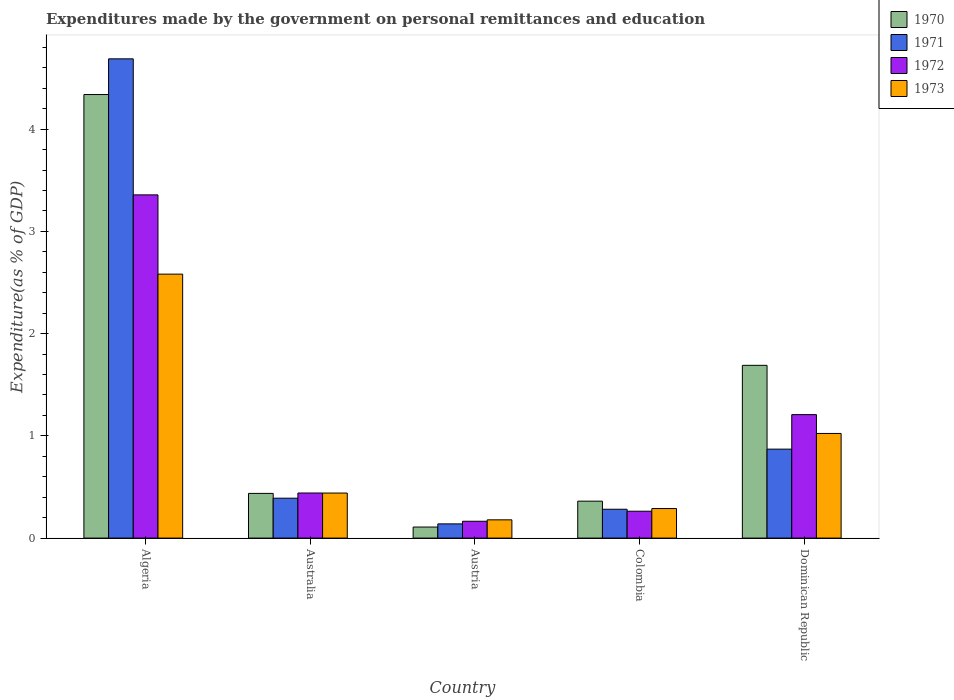How many different coloured bars are there?
Ensure brevity in your answer.  4. How many groups of bars are there?
Your answer should be compact. 5. Are the number of bars on each tick of the X-axis equal?
Offer a terse response. Yes. How many bars are there on the 5th tick from the left?
Provide a short and direct response. 4. What is the label of the 3rd group of bars from the left?
Make the answer very short. Austria. In how many cases, is the number of bars for a given country not equal to the number of legend labels?
Provide a short and direct response. 0. What is the expenditures made by the government on personal remittances and education in 1973 in Australia?
Ensure brevity in your answer.  0.44. Across all countries, what is the maximum expenditures made by the government on personal remittances and education in 1973?
Ensure brevity in your answer.  2.58. Across all countries, what is the minimum expenditures made by the government on personal remittances and education in 1973?
Ensure brevity in your answer.  0.18. In which country was the expenditures made by the government on personal remittances and education in 1971 maximum?
Provide a succinct answer. Algeria. In which country was the expenditures made by the government on personal remittances and education in 1970 minimum?
Your answer should be compact. Austria. What is the total expenditures made by the government on personal remittances and education in 1973 in the graph?
Your answer should be compact. 4.51. What is the difference between the expenditures made by the government on personal remittances and education in 1973 in Australia and that in Dominican Republic?
Your answer should be compact. -0.58. What is the difference between the expenditures made by the government on personal remittances and education in 1973 in Colombia and the expenditures made by the government on personal remittances and education in 1971 in Dominican Republic?
Your answer should be compact. -0.58. What is the average expenditures made by the government on personal remittances and education in 1971 per country?
Make the answer very short. 1.27. What is the difference between the expenditures made by the government on personal remittances and education of/in 1972 and expenditures made by the government on personal remittances and education of/in 1970 in Algeria?
Provide a succinct answer. -0.98. What is the ratio of the expenditures made by the government on personal remittances and education in 1972 in Australia to that in Austria?
Provide a short and direct response. 2.68. What is the difference between the highest and the second highest expenditures made by the government on personal remittances and education in 1971?
Provide a short and direct response. 0.48. What is the difference between the highest and the lowest expenditures made by the government on personal remittances and education in 1973?
Offer a terse response. 2.4. Is the sum of the expenditures made by the government on personal remittances and education in 1971 in Australia and Colombia greater than the maximum expenditures made by the government on personal remittances and education in 1973 across all countries?
Make the answer very short. No. Is it the case that in every country, the sum of the expenditures made by the government on personal remittances and education in 1973 and expenditures made by the government on personal remittances and education in 1970 is greater than the sum of expenditures made by the government on personal remittances and education in 1971 and expenditures made by the government on personal remittances and education in 1972?
Ensure brevity in your answer.  No. What does the 1st bar from the left in Australia represents?
Keep it short and to the point. 1970. What does the 3rd bar from the right in Australia represents?
Your answer should be very brief. 1971. Is it the case that in every country, the sum of the expenditures made by the government on personal remittances and education in 1973 and expenditures made by the government on personal remittances and education in 1972 is greater than the expenditures made by the government on personal remittances and education in 1971?
Offer a terse response. Yes. How many bars are there?
Your answer should be compact. 20. Are all the bars in the graph horizontal?
Your answer should be compact. No. How many countries are there in the graph?
Offer a terse response. 5. Does the graph contain any zero values?
Keep it short and to the point. No. How many legend labels are there?
Offer a terse response. 4. How are the legend labels stacked?
Give a very brief answer. Vertical. What is the title of the graph?
Give a very brief answer. Expenditures made by the government on personal remittances and education. Does "1999" appear as one of the legend labels in the graph?
Your answer should be compact. No. What is the label or title of the X-axis?
Keep it short and to the point. Country. What is the label or title of the Y-axis?
Your answer should be compact. Expenditure(as % of GDP). What is the Expenditure(as % of GDP) of 1970 in Algeria?
Your answer should be compact. 4.34. What is the Expenditure(as % of GDP) in 1971 in Algeria?
Offer a terse response. 4.69. What is the Expenditure(as % of GDP) in 1972 in Algeria?
Provide a short and direct response. 3.36. What is the Expenditure(as % of GDP) of 1973 in Algeria?
Make the answer very short. 2.58. What is the Expenditure(as % of GDP) in 1970 in Australia?
Keep it short and to the point. 0.44. What is the Expenditure(as % of GDP) in 1971 in Australia?
Give a very brief answer. 0.39. What is the Expenditure(as % of GDP) of 1972 in Australia?
Keep it short and to the point. 0.44. What is the Expenditure(as % of GDP) in 1973 in Australia?
Give a very brief answer. 0.44. What is the Expenditure(as % of GDP) in 1970 in Austria?
Give a very brief answer. 0.11. What is the Expenditure(as % of GDP) of 1971 in Austria?
Offer a terse response. 0.14. What is the Expenditure(as % of GDP) in 1972 in Austria?
Offer a terse response. 0.16. What is the Expenditure(as % of GDP) in 1973 in Austria?
Your answer should be compact. 0.18. What is the Expenditure(as % of GDP) in 1970 in Colombia?
Keep it short and to the point. 0.36. What is the Expenditure(as % of GDP) in 1971 in Colombia?
Keep it short and to the point. 0.28. What is the Expenditure(as % of GDP) in 1972 in Colombia?
Make the answer very short. 0.26. What is the Expenditure(as % of GDP) in 1973 in Colombia?
Keep it short and to the point. 0.29. What is the Expenditure(as % of GDP) in 1970 in Dominican Republic?
Make the answer very short. 1.69. What is the Expenditure(as % of GDP) in 1971 in Dominican Republic?
Offer a very short reply. 0.87. What is the Expenditure(as % of GDP) of 1972 in Dominican Republic?
Provide a short and direct response. 1.21. What is the Expenditure(as % of GDP) of 1973 in Dominican Republic?
Your answer should be compact. 1.02. Across all countries, what is the maximum Expenditure(as % of GDP) of 1970?
Offer a very short reply. 4.34. Across all countries, what is the maximum Expenditure(as % of GDP) of 1971?
Your response must be concise. 4.69. Across all countries, what is the maximum Expenditure(as % of GDP) of 1972?
Your response must be concise. 3.36. Across all countries, what is the maximum Expenditure(as % of GDP) of 1973?
Give a very brief answer. 2.58. Across all countries, what is the minimum Expenditure(as % of GDP) of 1970?
Your answer should be compact. 0.11. Across all countries, what is the minimum Expenditure(as % of GDP) of 1971?
Give a very brief answer. 0.14. Across all countries, what is the minimum Expenditure(as % of GDP) in 1972?
Give a very brief answer. 0.16. Across all countries, what is the minimum Expenditure(as % of GDP) of 1973?
Your answer should be very brief. 0.18. What is the total Expenditure(as % of GDP) in 1970 in the graph?
Your answer should be very brief. 6.93. What is the total Expenditure(as % of GDP) of 1971 in the graph?
Offer a terse response. 6.37. What is the total Expenditure(as % of GDP) of 1972 in the graph?
Provide a succinct answer. 5.43. What is the total Expenditure(as % of GDP) in 1973 in the graph?
Offer a very short reply. 4.51. What is the difference between the Expenditure(as % of GDP) in 1970 in Algeria and that in Australia?
Make the answer very short. 3.9. What is the difference between the Expenditure(as % of GDP) of 1971 in Algeria and that in Australia?
Provide a short and direct response. 4.3. What is the difference between the Expenditure(as % of GDP) in 1972 in Algeria and that in Australia?
Give a very brief answer. 2.92. What is the difference between the Expenditure(as % of GDP) of 1973 in Algeria and that in Australia?
Your answer should be very brief. 2.14. What is the difference between the Expenditure(as % of GDP) in 1970 in Algeria and that in Austria?
Offer a terse response. 4.23. What is the difference between the Expenditure(as % of GDP) of 1971 in Algeria and that in Austria?
Provide a succinct answer. 4.55. What is the difference between the Expenditure(as % of GDP) of 1972 in Algeria and that in Austria?
Your answer should be compact. 3.19. What is the difference between the Expenditure(as % of GDP) in 1973 in Algeria and that in Austria?
Ensure brevity in your answer.  2.4. What is the difference between the Expenditure(as % of GDP) of 1970 in Algeria and that in Colombia?
Provide a succinct answer. 3.98. What is the difference between the Expenditure(as % of GDP) in 1971 in Algeria and that in Colombia?
Make the answer very short. 4.41. What is the difference between the Expenditure(as % of GDP) of 1972 in Algeria and that in Colombia?
Provide a succinct answer. 3.09. What is the difference between the Expenditure(as % of GDP) in 1973 in Algeria and that in Colombia?
Make the answer very short. 2.29. What is the difference between the Expenditure(as % of GDP) of 1970 in Algeria and that in Dominican Republic?
Provide a succinct answer. 2.65. What is the difference between the Expenditure(as % of GDP) in 1971 in Algeria and that in Dominican Republic?
Ensure brevity in your answer.  3.82. What is the difference between the Expenditure(as % of GDP) of 1972 in Algeria and that in Dominican Republic?
Offer a very short reply. 2.15. What is the difference between the Expenditure(as % of GDP) of 1973 in Algeria and that in Dominican Republic?
Keep it short and to the point. 1.56. What is the difference between the Expenditure(as % of GDP) in 1970 in Australia and that in Austria?
Provide a succinct answer. 0.33. What is the difference between the Expenditure(as % of GDP) of 1971 in Australia and that in Austria?
Give a very brief answer. 0.25. What is the difference between the Expenditure(as % of GDP) in 1972 in Australia and that in Austria?
Provide a succinct answer. 0.28. What is the difference between the Expenditure(as % of GDP) in 1973 in Australia and that in Austria?
Make the answer very short. 0.26. What is the difference between the Expenditure(as % of GDP) of 1970 in Australia and that in Colombia?
Give a very brief answer. 0.08. What is the difference between the Expenditure(as % of GDP) in 1971 in Australia and that in Colombia?
Make the answer very short. 0.11. What is the difference between the Expenditure(as % of GDP) of 1972 in Australia and that in Colombia?
Offer a terse response. 0.18. What is the difference between the Expenditure(as % of GDP) of 1973 in Australia and that in Colombia?
Give a very brief answer. 0.15. What is the difference between the Expenditure(as % of GDP) in 1970 in Australia and that in Dominican Republic?
Give a very brief answer. -1.25. What is the difference between the Expenditure(as % of GDP) of 1971 in Australia and that in Dominican Republic?
Your answer should be compact. -0.48. What is the difference between the Expenditure(as % of GDP) of 1972 in Australia and that in Dominican Republic?
Your response must be concise. -0.77. What is the difference between the Expenditure(as % of GDP) in 1973 in Australia and that in Dominican Republic?
Your answer should be very brief. -0.58. What is the difference between the Expenditure(as % of GDP) in 1970 in Austria and that in Colombia?
Your answer should be very brief. -0.25. What is the difference between the Expenditure(as % of GDP) in 1971 in Austria and that in Colombia?
Keep it short and to the point. -0.14. What is the difference between the Expenditure(as % of GDP) of 1972 in Austria and that in Colombia?
Provide a succinct answer. -0.1. What is the difference between the Expenditure(as % of GDP) of 1973 in Austria and that in Colombia?
Offer a terse response. -0.11. What is the difference between the Expenditure(as % of GDP) of 1970 in Austria and that in Dominican Republic?
Ensure brevity in your answer.  -1.58. What is the difference between the Expenditure(as % of GDP) of 1971 in Austria and that in Dominican Republic?
Offer a very short reply. -0.73. What is the difference between the Expenditure(as % of GDP) in 1972 in Austria and that in Dominican Republic?
Offer a terse response. -1.04. What is the difference between the Expenditure(as % of GDP) in 1973 in Austria and that in Dominican Republic?
Offer a very short reply. -0.84. What is the difference between the Expenditure(as % of GDP) of 1970 in Colombia and that in Dominican Republic?
Your answer should be compact. -1.33. What is the difference between the Expenditure(as % of GDP) in 1971 in Colombia and that in Dominican Republic?
Make the answer very short. -0.59. What is the difference between the Expenditure(as % of GDP) of 1972 in Colombia and that in Dominican Republic?
Ensure brevity in your answer.  -0.94. What is the difference between the Expenditure(as % of GDP) of 1973 in Colombia and that in Dominican Republic?
Make the answer very short. -0.73. What is the difference between the Expenditure(as % of GDP) of 1970 in Algeria and the Expenditure(as % of GDP) of 1971 in Australia?
Make the answer very short. 3.95. What is the difference between the Expenditure(as % of GDP) of 1970 in Algeria and the Expenditure(as % of GDP) of 1972 in Australia?
Offer a very short reply. 3.9. What is the difference between the Expenditure(as % of GDP) in 1970 in Algeria and the Expenditure(as % of GDP) in 1973 in Australia?
Offer a terse response. 3.9. What is the difference between the Expenditure(as % of GDP) in 1971 in Algeria and the Expenditure(as % of GDP) in 1972 in Australia?
Make the answer very short. 4.25. What is the difference between the Expenditure(as % of GDP) in 1971 in Algeria and the Expenditure(as % of GDP) in 1973 in Australia?
Make the answer very short. 4.25. What is the difference between the Expenditure(as % of GDP) of 1972 in Algeria and the Expenditure(as % of GDP) of 1973 in Australia?
Your response must be concise. 2.92. What is the difference between the Expenditure(as % of GDP) of 1970 in Algeria and the Expenditure(as % of GDP) of 1971 in Austria?
Offer a terse response. 4.2. What is the difference between the Expenditure(as % of GDP) in 1970 in Algeria and the Expenditure(as % of GDP) in 1972 in Austria?
Your answer should be very brief. 4.17. What is the difference between the Expenditure(as % of GDP) of 1970 in Algeria and the Expenditure(as % of GDP) of 1973 in Austria?
Your answer should be very brief. 4.16. What is the difference between the Expenditure(as % of GDP) of 1971 in Algeria and the Expenditure(as % of GDP) of 1972 in Austria?
Make the answer very short. 4.52. What is the difference between the Expenditure(as % of GDP) of 1971 in Algeria and the Expenditure(as % of GDP) of 1973 in Austria?
Your response must be concise. 4.51. What is the difference between the Expenditure(as % of GDP) in 1972 in Algeria and the Expenditure(as % of GDP) in 1973 in Austria?
Ensure brevity in your answer.  3.18. What is the difference between the Expenditure(as % of GDP) in 1970 in Algeria and the Expenditure(as % of GDP) in 1971 in Colombia?
Your response must be concise. 4.06. What is the difference between the Expenditure(as % of GDP) in 1970 in Algeria and the Expenditure(as % of GDP) in 1972 in Colombia?
Keep it short and to the point. 4.08. What is the difference between the Expenditure(as % of GDP) in 1970 in Algeria and the Expenditure(as % of GDP) in 1973 in Colombia?
Your response must be concise. 4.05. What is the difference between the Expenditure(as % of GDP) in 1971 in Algeria and the Expenditure(as % of GDP) in 1972 in Colombia?
Offer a very short reply. 4.42. What is the difference between the Expenditure(as % of GDP) in 1971 in Algeria and the Expenditure(as % of GDP) in 1973 in Colombia?
Your response must be concise. 4.4. What is the difference between the Expenditure(as % of GDP) in 1972 in Algeria and the Expenditure(as % of GDP) in 1973 in Colombia?
Your answer should be very brief. 3.07. What is the difference between the Expenditure(as % of GDP) in 1970 in Algeria and the Expenditure(as % of GDP) in 1971 in Dominican Republic?
Keep it short and to the point. 3.47. What is the difference between the Expenditure(as % of GDP) of 1970 in Algeria and the Expenditure(as % of GDP) of 1972 in Dominican Republic?
Your answer should be compact. 3.13. What is the difference between the Expenditure(as % of GDP) in 1970 in Algeria and the Expenditure(as % of GDP) in 1973 in Dominican Republic?
Your response must be concise. 3.31. What is the difference between the Expenditure(as % of GDP) in 1971 in Algeria and the Expenditure(as % of GDP) in 1972 in Dominican Republic?
Provide a short and direct response. 3.48. What is the difference between the Expenditure(as % of GDP) in 1971 in Algeria and the Expenditure(as % of GDP) in 1973 in Dominican Republic?
Offer a terse response. 3.66. What is the difference between the Expenditure(as % of GDP) of 1972 in Algeria and the Expenditure(as % of GDP) of 1973 in Dominican Republic?
Give a very brief answer. 2.33. What is the difference between the Expenditure(as % of GDP) of 1970 in Australia and the Expenditure(as % of GDP) of 1971 in Austria?
Give a very brief answer. 0.3. What is the difference between the Expenditure(as % of GDP) of 1970 in Australia and the Expenditure(as % of GDP) of 1972 in Austria?
Offer a terse response. 0.27. What is the difference between the Expenditure(as % of GDP) of 1970 in Australia and the Expenditure(as % of GDP) of 1973 in Austria?
Provide a short and direct response. 0.26. What is the difference between the Expenditure(as % of GDP) in 1971 in Australia and the Expenditure(as % of GDP) in 1972 in Austria?
Give a very brief answer. 0.23. What is the difference between the Expenditure(as % of GDP) of 1971 in Australia and the Expenditure(as % of GDP) of 1973 in Austria?
Give a very brief answer. 0.21. What is the difference between the Expenditure(as % of GDP) in 1972 in Australia and the Expenditure(as % of GDP) in 1973 in Austria?
Offer a very short reply. 0.26. What is the difference between the Expenditure(as % of GDP) of 1970 in Australia and the Expenditure(as % of GDP) of 1971 in Colombia?
Provide a short and direct response. 0.15. What is the difference between the Expenditure(as % of GDP) of 1970 in Australia and the Expenditure(as % of GDP) of 1972 in Colombia?
Your answer should be compact. 0.17. What is the difference between the Expenditure(as % of GDP) in 1970 in Australia and the Expenditure(as % of GDP) in 1973 in Colombia?
Ensure brevity in your answer.  0.15. What is the difference between the Expenditure(as % of GDP) of 1971 in Australia and the Expenditure(as % of GDP) of 1972 in Colombia?
Offer a very short reply. 0.13. What is the difference between the Expenditure(as % of GDP) of 1971 in Australia and the Expenditure(as % of GDP) of 1973 in Colombia?
Give a very brief answer. 0.1. What is the difference between the Expenditure(as % of GDP) in 1972 in Australia and the Expenditure(as % of GDP) in 1973 in Colombia?
Provide a short and direct response. 0.15. What is the difference between the Expenditure(as % of GDP) of 1970 in Australia and the Expenditure(as % of GDP) of 1971 in Dominican Republic?
Offer a terse response. -0.43. What is the difference between the Expenditure(as % of GDP) of 1970 in Australia and the Expenditure(as % of GDP) of 1972 in Dominican Republic?
Provide a succinct answer. -0.77. What is the difference between the Expenditure(as % of GDP) in 1970 in Australia and the Expenditure(as % of GDP) in 1973 in Dominican Republic?
Your answer should be compact. -0.59. What is the difference between the Expenditure(as % of GDP) of 1971 in Australia and the Expenditure(as % of GDP) of 1972 in Dominican Republic?
Your response must be concise. -0.82. What is the difference between the Expenditure(as % of GDP) in 1971 in Australia and the Expenditure(as % of GDP) in 1973 in Dominican Republic?
Your response must be concise. -0.63. What is the difference between the Expenditure(as % of GDP) in 1972 in Australia and the Expenditure(as % of GDP) in 1973 in Dominican Republic?
Ensure brevity in your answer.  -0.58. What is the difference between the Expenditure(as % of GDP) of 1970 in Austria and the Expenditure(as % of GDP) of 1971 in Colombia?
Your response must be concise. -0.17. What is the difference between the Expenditure(as % of GDP) of 1970 in Austria and the Expenditure(as % of GDP) of 1972 in Colombia?
Provide a short and direct response. -0.15. What is the difference between the Expenditure(as % of GDP) of 1970 in Austria and the Expenditure(as % of GDP) of 1973 in Colombia?
Offer a very short reply. -0.18. What is the difference between the Expenditure(as % of GDP) of 1971 in Austria and the Expenditure(as % of GDP) of 1972 in Colombia?
Make the answer very short. -0.12. What is the difference between the Expenditure(as % of GDP) of 1971 in Austria and the Expenditure(as % of GDP) of 1973 in Colombia?
Your answer should be compact. -0.15. What is the difference between the Expenditure(as % of GDP) in 1972 in Austria and the Expenditure(as % of GDP) in 1973 in Colombia?
Make the answer very short. -0.12. What is the difference between the Expenditure(as % of GDP) in 1970 in Austria and the Expenditure(as % of GDP) in 1971 in Dominican Republic?
Provide a short and direct response. -0.76. What is the difference between the Expenditure(as % of GDP) in 1970 in Austria and the Expenditure(as % of GDP) in 1972 in Dominican Republic?
Ensure brevity in your answer.  -1.1. What is the difference between the Expenditure(as % of GDP) of 1970 in Austria and the Expenditure(as % of GDP) of 1973 in Dominican Republic?
Your answer should be very brief. -0.92. What is the difference between the Expenditure(as % of GDP) in 1971 in Austria and the Expenditure(as % of GDP) in 1972 in Dominican Republic?
Your answer should be compact. -1.07. What is the difference between the Expenditure(as % of GDP) in 1971 in Austria and the Expenditure(as % of GDP) in 1973 in Dominican Republic?
Offer a terse response. -0.88. What is the difference between the Expenditure(as % of GDP) in 1972 in Austria and the Expenditure(as % of GDP) in 1973 in Dominican Republic?
Your answer should be compact. -0.86. What is the difference between the Expenditure(as % of GDP) of 1970 in Colombia and the Expenditure(as % of GDP) of 1971 in Dominican Republic?
Make the answer very short. -0.51. What is the difference between the Expenditure(as % of GDP) in 1970 in Colombia and the Expenditure(as % of GDP) in 1972 in Dominican Republic?
Provide a short and direct response. -0.85. What is the difference between the Expenditure(as % of GDP) of 1970 in Colombia and the Expenditure(as % of GDP) of 1973 in Dominican Republic?
Offer a very short reply. -0.66. What is the difference between the Expenditure(as % of GDP) of 1971 in Colombia and the Expenditure(as % of GDP) of 1972 in Dominican Republic?
Offer a very short reply. -0.93. What is the difference between the Expenditure(as % of GDP) of 1971 in Colombia and the Expenditure(as % of GDP) of 1973 in Dominican Republic?
Keep it short and to the point. -0.74. What is the difference between the Expenditure(as % of GDP) in 1972 in Colombia and the Expenditure(as % of GDP) in 1973 in Dominican Republic?
Ensure brevity in your answer.  -0.76. What is the average Expenditure(as % of GDP) in 1970 per country?
Provide a succinct answer. 1.39. What is the average Expenditure(as % of GDP) of 1971 per country?
Offer a terse response. 1.27. What is the average Expenditure(as % of GDP) in 1972 per country?
Give a very brief answer. 1.09. What is the average Expenditure(as % of GDP) of 1973 per country?
Your answer should be compact. 0.9. What is the difference between the Expenditure(as % of GDP) of 1970 and Expenditure(as % of GDP) of 1971 in Algeria?
Your response must be concise. -0.35. What is the difference between the Expenditure(as % of GDP) of 1970 and Expenditure(as % of GDP) of 1972 in Algeria?
Your answer should be very brief. 0.98. What is the difference between the Expenditure(as % of GDP) in 1970 and Expenditure(as % of GDP) in 1973 in Algeria?
Provide a succinct answer. 1.76. What is the difference between the Expenditure(as % of GDP) in 1971 and Expenditure(as % of GDP) in 1972 in Algeria?
Offer a terse response. 1.33. What is the difference between the Expenditure(as % of GDP) in 1971 and Expenditure(as % of GDP) in 1973 in Algeria?
Offer a very short reply. 2.11. What is the difference between the Expenditure(as % of GDP) in 1972 and Expenditure(as % of GDP) in 1973 in Algeria?
Offer a very short reply. 0.78. What is the difference between the Expenditure(as % of GDP) of 1970 and Expenditure(as % of GDP) of 1971 in Australia?
Offer a terse response. 0.05. What is the difference between the Expenditure(as % of GDP) of 1970 and Expenditure(as % of GDP) of 1972 in Australia?
Offer a very short reply. -0. What is the difference between the Expenditure(as % of GDP) in 1970 and Expenditure(as % of GDP) in 1973 in Australia?
Make the answer very short. -0. What is the difference between the Expenditure(as % of GDP) in 1971 and Expenditure(as % of GDP) in 1972 in Australia?
Your response must be concise. -0.05. What is the difference between the Expenditure(as % of GDP) in 1971 and Expenditure(as % of GDP) in 1973 in Australia?
Offer a terse response. -0.05. What is the difference between the Expenditure(as % of GDP) in 1972 and Expenditure(as % of GDP) in 1973 in Australia?
Provide a short and direct response. 0. What is the difference between the Expenditure(as % of GDP) in 1970 and Expenditure(as % of GDP) in 1971 in Austria?
Keep it short and to the point. -0.03. What is the difference between the Expenditure(as % of GDP) in 1970 and Expenditure(as % of GDP) in 1972 in Austria?
Offer a very short reply. -0.06. What is the difference between the Expenditure(as % of GDP) in 1970 and Expenditure(as % of GDP) in 1973 in Austria?
Your response must be concise. -0.07. What is the difference between the Expenditure(as % of GDP) in 1971 and Expenditure(as % of GDP) in 1972 in Austria?
Offer a terse response. -0.03. What is the difference between the Expenditure(as % of GDP) of 1971 and Expenditure(as % of GDP) of 1973 in Austria?
Your answer should be very brief. -0.04. What is the difference between the Expenditure(as % of GDP) in 1972 and Expenditure(as % of GDP) in 1973 in Austria?
Offer a terse response. -0.01. What is the difference between the Expenditure(as % of GDP) of 1970 and Expenditure(as % of GDP) of 1971 in Colombia?
Keep it short and to the point. 0.08. What is the difference between the Expenditure(as % of GDP) of 1970 and Expenditure(as % of GDP) of 1972 in Colombia?
Your answer should be very brief. 0.1. What is the difference between the Expenditure(as % of GDP) of 1970 and Expenditure(as % of GDP) of 1973 in Colombia?
Your response must be concise. 0.07. What is the difference between the Expenditure(as % of GDP) in 1971 and Expenditure(as % of GDP) in 1972 in Colombia?
Your response must be concise. 0.02. What is the difference between the Expenditure(as % of GDP) in 1971 and Expenditure(as % of GDP) in 1973 in Colombia?
Your answer should be compact. -0.01. What is the difference between the Expenditure(as % of GDP) in 1972 and Expenditure(as % of GDP) in 1973 in Colombia?
Give a very brief answer. -0.03. What is the difference between the Expenditure(as % of GDP) in 1970 and Expenditure(as % of GDP) in 1971 in Dominican Republic?
Make the answer very short. 0.82. What is the difference between the Expenditure(as % of GDP) in 1970 and Expenditure(as % of GDP) in 1972 in Dominican Republic?
Provide a short and direct response. 0.48. What is the difference between the Expenditure(as % of GDP) of 1970 and Expenditure(as % of GDP) of 1973 in Dominican Republic?
Offer a very short reply. 0.67. What is the difference between the Expenditure(as % of GDP) in 1971 and Expenditure(as % of GDP) in 1972 in Dominican Republic?
Give a very brief answer. -0.34. What is the difference between the Expenditure(as % of GDP) in 1971 and Expenditure(as % of GDP) in 1973 in Dominican Republic?
Provide a short and direct response. -0.15. What is the difference between the Expenditure(as % of GDP) in 1972 and Expenditure(as % of GDP) in 1973 in Dominican Republic?
Your answer should be very brief. 0.18. What is the ratio of the Expenditure(as % of GDP) of 1970 in Algeria to that in Australia?
Give a very brief answer. 9.92. What is the ratio of the Expenditure(as % of GDP) of 1971 in Algeria to that in Australia?
Provide a succinct answer. 12.01. What is the ratio of the Expenditure(as % of GDP) of 1972 in Algeria to that in Australia?
Your answer should be compact. 7.61. What is the ratio of the Expenditure(as % of GDP) of 1973 in Algeria to that in Australia?
Your response must be concise. 5.86. What is the ratio of the Expenditure(as % of GDP) in 1970 in Algeria to that in Austria?
Your answer should be very brief. 40.14. What is the ratio of the Expenditure(as % of GDP) in 1971 in Algeria to that in Austria?
Keep it short and to the point. 33.73. What is the ratio of the Expenditure(as % of GDP) of 1972 in Algeria to that in Austria?
Your answer should be very brief. 20.38. What is the ratio of the Expenditure(as % of GDP) of 1973 in Algeria to that in Austria?
Your answer should be very brief. 14.45. What is the ratio of the Expenditure(as % of GDP) of 1970 in Algeria to that in Colombia?
Provide a succinct answer. 12.01. What is the ratio of the Expenditure(as % of GDP) in 1971 in Algeria to that in Colombia?
Give a very brief answer. 16.61. What is the ratio of the Expenditure(as % of GDP) in 1972 in Algeria to that in Colombia?
Keep it short and to the point. 12.77. What is the ratio of the Expenditure(as % of GDP) in 1973 in Algeria to that in Colombia?
Offer a very short reply. 8.94. What is the ratio of the Expenditure(as % of GDP) of 1970 in Algeria to that in Dominican Republic?
Provide a succinct answer. 2.57. What is the ratio of the Expenditure(as % of GDP) in 1971 in Algeria to that in Dominican Republic?
Ensure brevity in your answer.  5.39. What is the ratio of the Expenditure(as % of GDP) in 1972 in Algeria to that in Dominican Republic?
Your answer should be very brief. 2.78. What is the ratio of the Expenditure(as % of GDP) of 1973 in Algeria to that in Dominican Republic?
Ensure brevity in your answer.  2.52. What is the ratio of the Expenditure(as % of GDP) of 1970 in Australia to that in Austria?
Provide a succinct answer. 4.04. What is the ratio of the Expenditure(as % of GDP) of 1971 in Australia to that in Austria?
Offer a very short reply. 2.81. What is the ratio of the Expenditure(as % of GDP) in 1972 in Australia to that in Austria?
Your response must be concise. 2.68. What is the ratio of the Expenditure(as % of GDP) in 1973 in Australia to that in Austria?
Provide a succinct answer. 2.47. What is the ratio of the Expenditure(as % of GDP) in 1970 in Australia to that in Colombia?
Offer a terse response. 1.21. What is the ratio of the Expenditure(as % of GDP) of 1971 in Australia to that in Colombia?
Offer a terse response. 1.38. What is the ratio of the Expenditure(as % of GDP) of 1972 in Australia to that in Colombia?
Offer a very short reply. 1.68. What is the ratio of the Expenditure(as % of GDP) of 1973 in Australia to that in Colombia?
Offer a very short reply. 1.52. What is the ratio of the Expenditure(as % of GDP) in 1970 in Australia to that in Dominican Republic?
Offer a terse response. 0.26. What is the ratio of the Expenditure(as % of GDP) of 1971 in Australia to that in Dominican Republic?
Keep it short and to the point. 0.45. What is the ratio of the Expenditure(as % of GDP) in 1972 in Australia to that in Dominican Republic?
Provide a short and direct response. 0.37. What is the ratio of the Expenditure(as % of GDP) of 1973 in Australia to that in Dominican Republic?
Keep it short and to the point. 0.43. What is the ratio of the Expenditure(as % of GDP) of 1970 in Austria to that in Colombia?
Provide a succinct answer. 0.3. What is the ratio of the Expenditure(as % of GDP) in 1971 in Austria to that in Colombia?
Make the answer very short. 0.49. What is the ratio of the Expenditure(as % of GDP) in 1972 in Austria to that in Colombia?
Provide a short and direct response. 0.63. What is the ratio of the Expenditure(as % of GDP) of 1973 in Austria to that in Colombia?
Ensure brevity in your answer.  0.62. What is the ratio of the Expenditure(as % of GDP) in 1970 in Austria to that in Dominican Republic?
Keep it short and to the point. 0.06. What is the ratio of the Expenditure(as % of GDP) of 1971 in Austria to that in Dominican Republic?
Offer a terse response. 0.16. What is the ratio of the Expenditure(as % of GDP) in 1972 in Austria to that in Dominican Republic?
Give a very brief answer. 0.14. What is the ratio of the Expenditure(as % of GDP) in 1973 in Austria to that in Dominican Republic?
Your answer should be compact. 0.17. What is the ratio of the Expenditure(as % of GDP) of 1970 in Colombia to that in Dominican Republic?
Your answer should be compact. 0.21. What is the ratio of the Expenditure(as % of GDP) of 1971 in Colombia to that in Dominican Republic?
Give a very brief answer. 0.32. What is the ratio of the Expenditure(as % of GDP) of 1972 in Colombia to that in Dominican Republic?
Provide a short and direct response. 0.22. What is the ratio of the Expenditure(as % of GDP) in 1973 in Colombia to that in Dominican Republic?
Offer a very short reply. 0.28. What is the difference between the highest and the second highest Expenditure(as % of GDP) of 1970?
Offer a terse response. 2.65. What is the difference between the highest and the second highest Expenditure(as % of GDP) of 1971?
Keep it short and to the point. 3.82. What is the difference between the highest and the second highest Expenditure(as % of GDP) in 1972?
Offer a terse response. 2.15. What is the difference between the highest and the second highest Expenditure(as % of GDP) of 1973?
Ensure brevity in your answer.  1.56. What is the difference between the highest and the lowest Expenditure(as % of GDP) of 1970?
Offer a terse response. 4.23. What is the difference between the highest and the lowest Expenditure(as % of GDP) in 1971?
Keep it short and to the point. 4.55. What is the difference between the highest and the lowest Expenditure(as % of GDP) in 1972?
Offer a very short reply. 3.19. What is the difference between the highest and the lowest Expenditure(as % of GDP) of 1973?
Give a very brief answer. 2.4. 